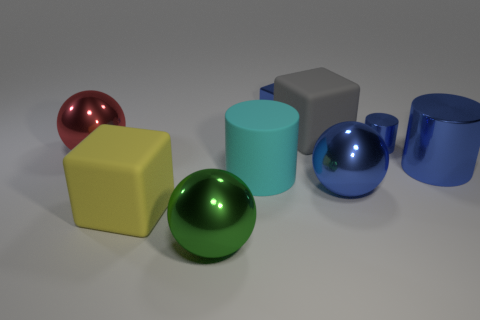There is a big green object that is the same shape as the red thing; what is its material?
Offer a terse response. Metal. What is the size of the other shiny cylinder that is the same color as the tiny cylinder?
Make the answer very short. Large. Do the small metal cylinder and the large metal thing in front of the big yellow matte cube have the same color?
Your answer should be compact. No. The rubber cylinder has what color?
Ensure brevity in your answer.  Cyan. What material is the big block on the left side of the green object?
Provide a succinct answer. Rubber. What is the size of the yellow matte thing that is the same shape as the gray thing?
Ensure brevity in your answer.  Large. Is the number of small objects in front of the yellow cube less than the number of tiny green blocks?
Your response must be concise. No. Are there any big metal objects?
Provide a succinct answer. Yes. There is a tiny shiny thing that is the same shape as the gray rubber object; what color is it?
Give a very brief answer. Blue. There is a large shiny object behind the large blue cylinder; is its color the same as the small metal cylinder?
Ensure brevity in your answer.  No. 